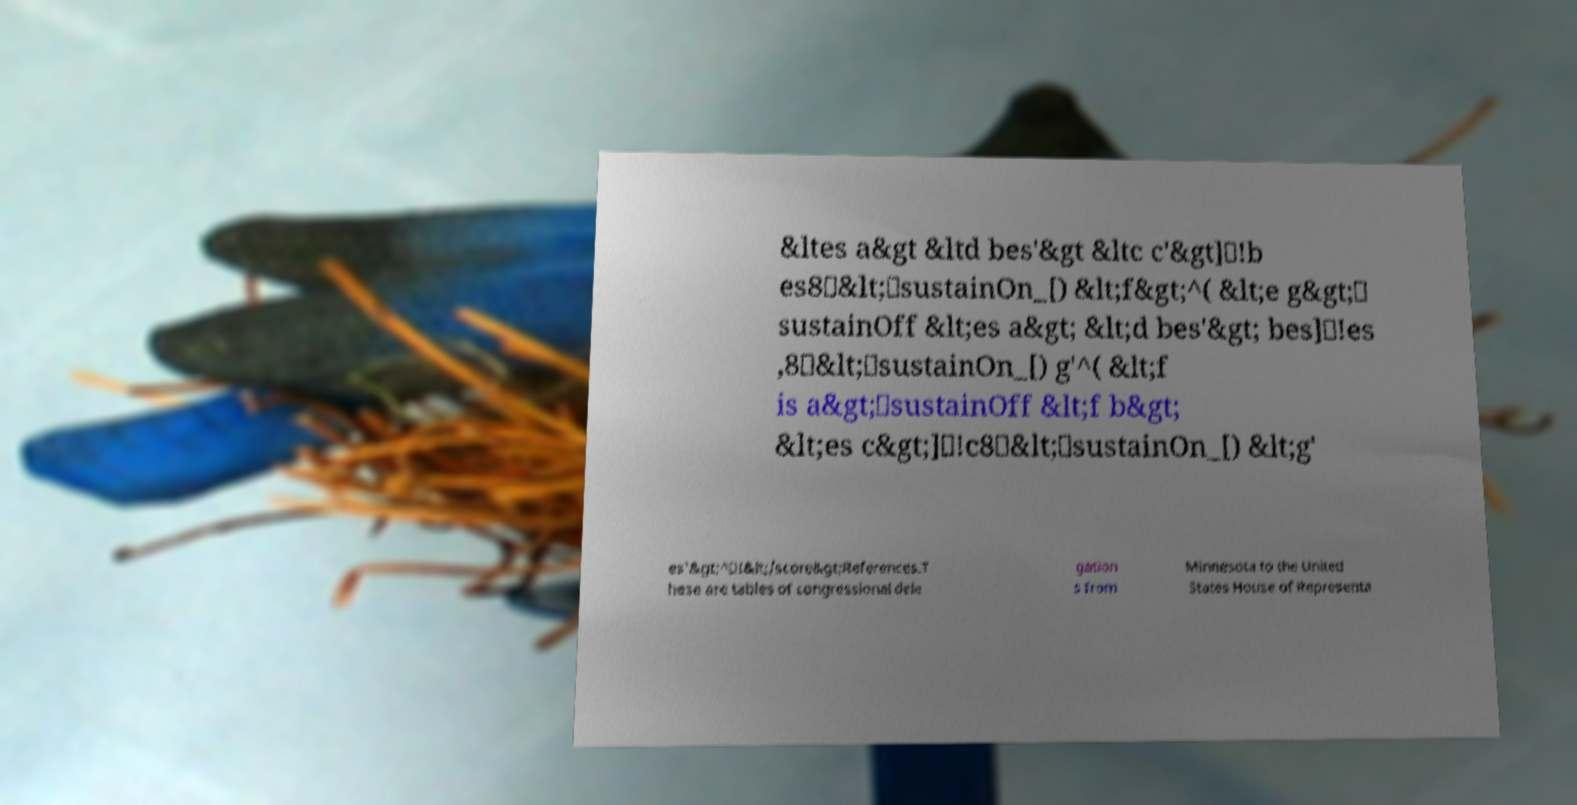Could you extract and type out the text from this image? &ltes a&gt &ltd bes'&gt &ltc c'&gt]\!b es8\&lt;\sustainOn_[) &lt;f&gt;^( &lt;e g&gt;\ sustainOff &lt;es a&gt; &lt;d bes'&gt; bes]\!es ,8\&lt;\sustainOn_[) g'^( &lt;f is a&gt;\sustainOff &lt;f b&gt; &lt;es c&gt;]\!c8\&lt;\sustainOn_[) &lt;g' es'&gt;^\!&lt;/score&gt;References.T hese are tables of congressional dele gation s from Minnesota to the United States House of Representa 